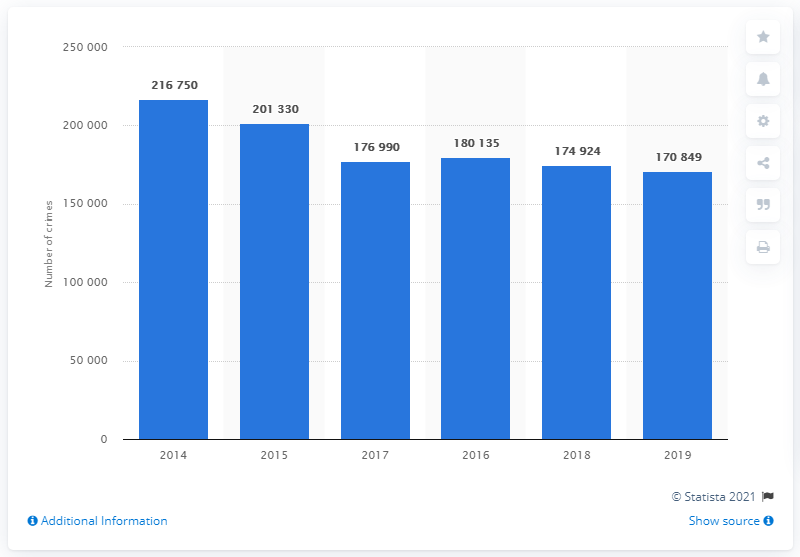Highlight a few significant elements in this photo. In 2019, the total number of crimes in Rome was 170,849. In 2014, a total of 216,750 crimes were registered by the police. In 2014, crime was at its highest level. The average number of crimes across all years is 186,829.666... 